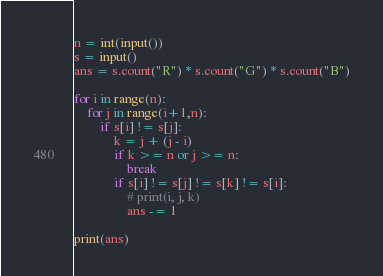Convert code to text. <code><loc_0><loc_0><loc_500><loc_500><_Python_>n = int(input())
s = input()
ans = s.count("R") * s.count("G") * s.count("B")

for i in range(n):
    for j in range(i+1,n):
        if s[i] != s[j]:
            k = j + (j - i)
            if k >= n or j >= n:
                break
            if s[i] != s[j] != s[k] != s[i]:
                # print(i, j, k)
                ans -= 1

print(ans)</code> 